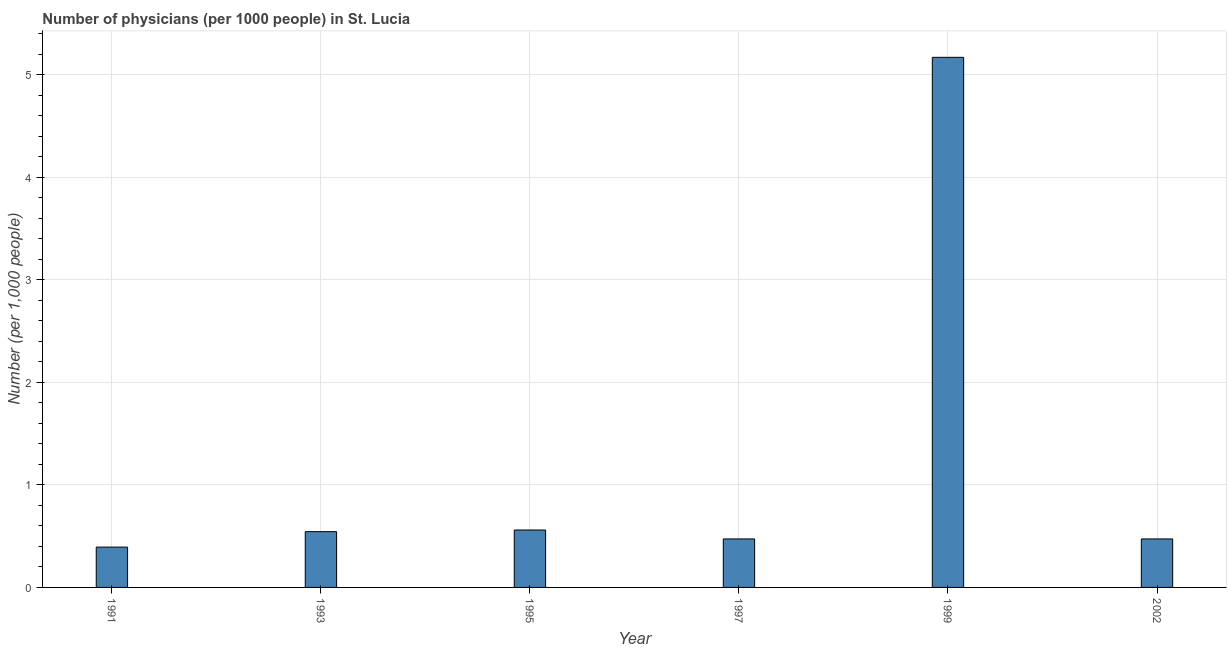Does the graph contain any zero values?
Make the answer very short. No. What is the title of the graph?
Your answer should be compact. Number of physicians (per 1000 people) in St. Lucia. What is the label or title of the X-axis?
Ensure brevity in your answer.  Year. What is the label or title of the Y-axis?
Ensure brevity in your answer.  Number (per 1,0 people). What is the number of physicians in 1991?
Keep it short and to the point. 0.39. Across all years, what is the maximum number of physicians?
Provide a short and direct response. 5.17. Across all years, what is the minimum number of physicians?
Provide a short and direct response. 0.39. What is the sum of the number of physicians?
Your answer should be compact. 7.61. What is the difference between the number of physicians in 1993 and 1995?
Provide a short and direct response. -0.02. What is the average number of physicians per year?
Give a very brief answer. 1.27. What is the median number of physicians?
Your response must be concise. 0.51. In how many years, is the number of physicians greater than 4.8 ?
Make the answer very short. 1. Do a majority of the years between 2002 and 1991 (inclusive) have number of physicians greater than 1.8 ?
Make the answer very short. Yes. What is the ratio of the number of physicians in 1993 to that in 1995?
Ensure brevity in your answer.  0.97. Is the difference between the number of physicians in 1993 and 1995 greater than the difference between any two years?
Provide a succinct answer. No. What is the difference between the highest and the second highest number of physicians?
Offer a very short reply. 4.61. What is the difference between the highest and the lowest number of physicians?
Your answer should be compact. 4.78. In how many years, is the number of physicians greater than the average number of physicians taken over all years?
Your answer should be compact. 1. What is the Number (per 1,000 people) in 1991?
Offer a very short reply. 0.39. What is the Number (per 1,000 people) in 1993?
Provide a short and direct response. 0.54. What is the Number (per 1,000 people) of 1995?
Make the answer very short. 0.56. What is the Number (per 1,000 people) in 1997?
Keep it short and to the point. 0.47. What is the Number (per 1,000 people) of 1999?
Offer a terse response. 5.17. What is the Number (per 1,000 people) of 2002?
Offer a terse response. 0.47. What is the difference between the Number (per 1,000 people) in 1991 and 1993?
Offer a terse response. -0.15. What is the difference between the Number (per 1,000 people) in 1991 and 1997?
Ensure brevity in your answer.  -0.08. What is the difference between the Number (per 1,000 people) in 1991 and 1999?
Your answer should be very brief. -4.78. What is the difference between the Number (per 1,000 people) in 1991 and 2002?
Provide a succinct answer. -0.08. What is the difference between the Number (per 1,000 people) in 1993 and 1995?
Your answer should be very brief. -0.02. What is the difference between the Number (per 1,000 people) in 1993 and 1997?
Give a very brief answer. 0.07. What is the difference between the Number (per 1,000 people) in 1993 and 1999?
Keep it short and to the point. -4.63. What is the difference between the Number (per 1,000 people) in 1993 and 2002?
Make the answer very short. 0.07. What is the difference between the Number (per 1,000 people) in 1995 and 1997?
Offer a very short reply. 0.09. What is the difference between the Number (per 1,000 people) in 1995 and 1999?
Provide a succinct answer. -4.61. What is the difference between the Number (per 1,000 people) in 1995 and 2002?
Make the answer very short. 0.09. What is the difference between the Number (per 1,000 people) in 1997 and 1999?
Your answer should be very brief. -4.7. What is the difference between the Number (per 1,000 people) in 1997 and 2002?
Provide a short and direct response. 0. What is the difference between the Number (per 1,000 people) in 1999 and 2002?
Provide a short and direct response. 4.7. What is the ratio of the Number (per 1,000 people) in 1991 to that in 1993?
Offer a terse response. 0.72. What is the ratio of the Number (per 1,000 people) in 1991 to that in 1995?
Your answer should be compact. 0.7. What is the ratio of the Number (per 1,000 people) in 1991 to that in 1997?
Ensure brevity in your answer.  0.83. What is the ratio of the Number (per 1,000 people) in 1991 to that in 1999?
Your response must be concise. 0.08. What is the ratio of the Number (per 1,000 people) in 1991 to that in 2002?
Provide a short and direct response. 0.83. What is the ratio of the Number (per 1,000 people) in 1993 to that in 1995?
Offer a very short reply. 0.97. What is the ratio of the Number (per 1,000 people) in 1993 to that in 1997?
Your response must be concise. 1.15. What is the ratio of the Number (per 1,000 people) in 1993 to that in 1999?
Ensure brevity in your answer.  0.1. What is the ratio of the Number (per 1,000 people) in 1993 to that in 2002?
Your answer should be very brief. 1.15. What is the ratio of the Number (per 1,000 people) in 1995 to that in 1997?
Keep it short and to the point. 1.18. What is the ratio of the Number (per 1,000 people) in 1995 to that in 1999?
Your response must be concise. 0.11. What is the ratio of the Number (per 1,000 people) in 1995 to that in 2002?
Give a very brief answer. 1.18. What is the ratio of the Number (per 1,000 people) in 1997 to that in 1999?
Offer a terse response. 0.09. What is the ratio of the Number (per 1,000 people) in 1997 to that in 2002?
Provide a short and direct response. 1. What is the ratio of the Number (per 1,000 people) in 1999 to that in 2002?
Provide a succinct answer. 10.93. 